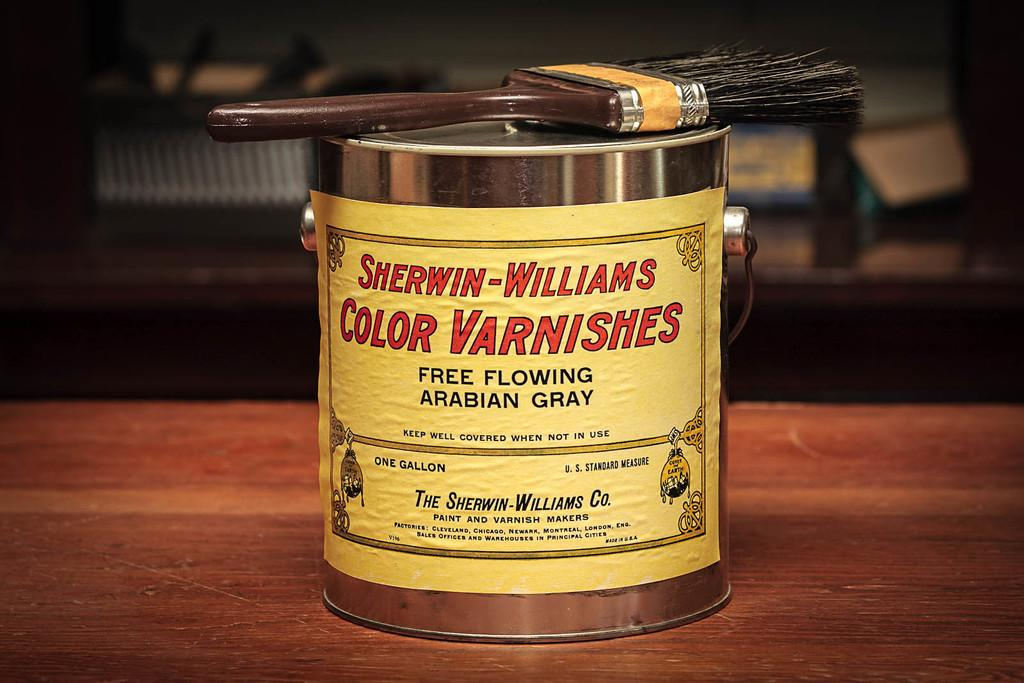<image>
Relay a brief, clear account of the picture shown. The can of varnish shown is from Sherwin-Williams 